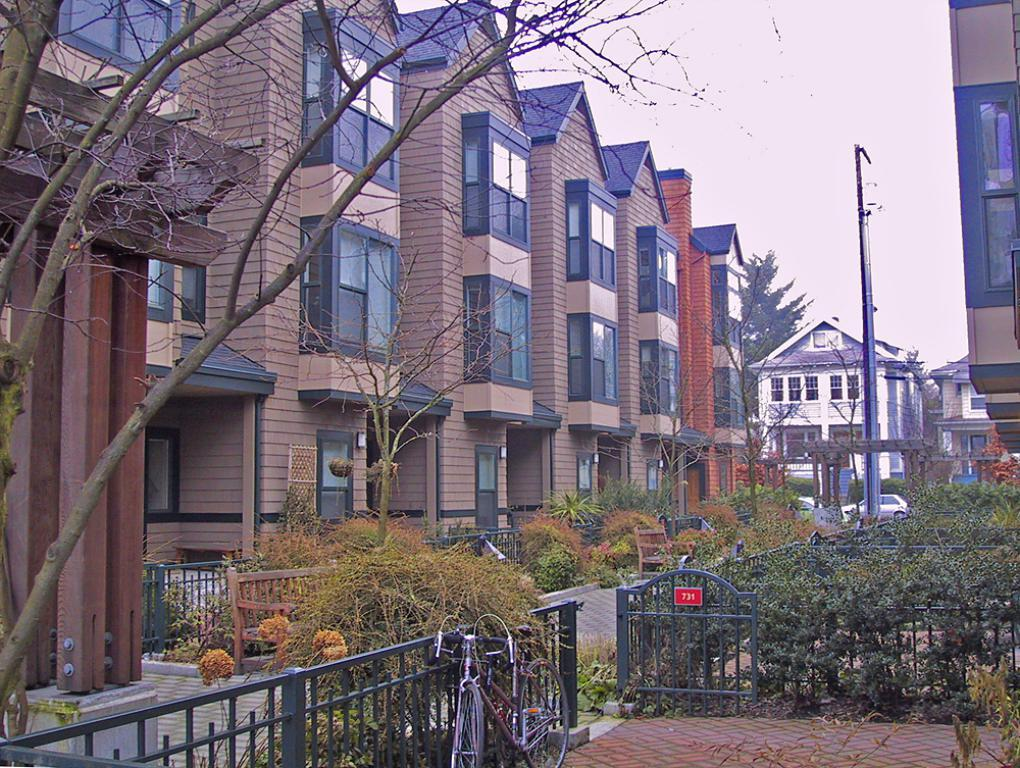What type of natural elements can be seen in the image? There are plants and trees in the image. What man-made structures are present in the image? There is a road, vehicles, buildings, an electric pole, and fencing in the image. What part of the natural environment is visible in the image? The sky is visible in the image. Can you tell me how many firemen are present in the image? There are no firemen present in the image. What type of care can be seen being provided to the plants in the image? There is no care being provided to the plants in the image; they are simply depicted in their natural state. 